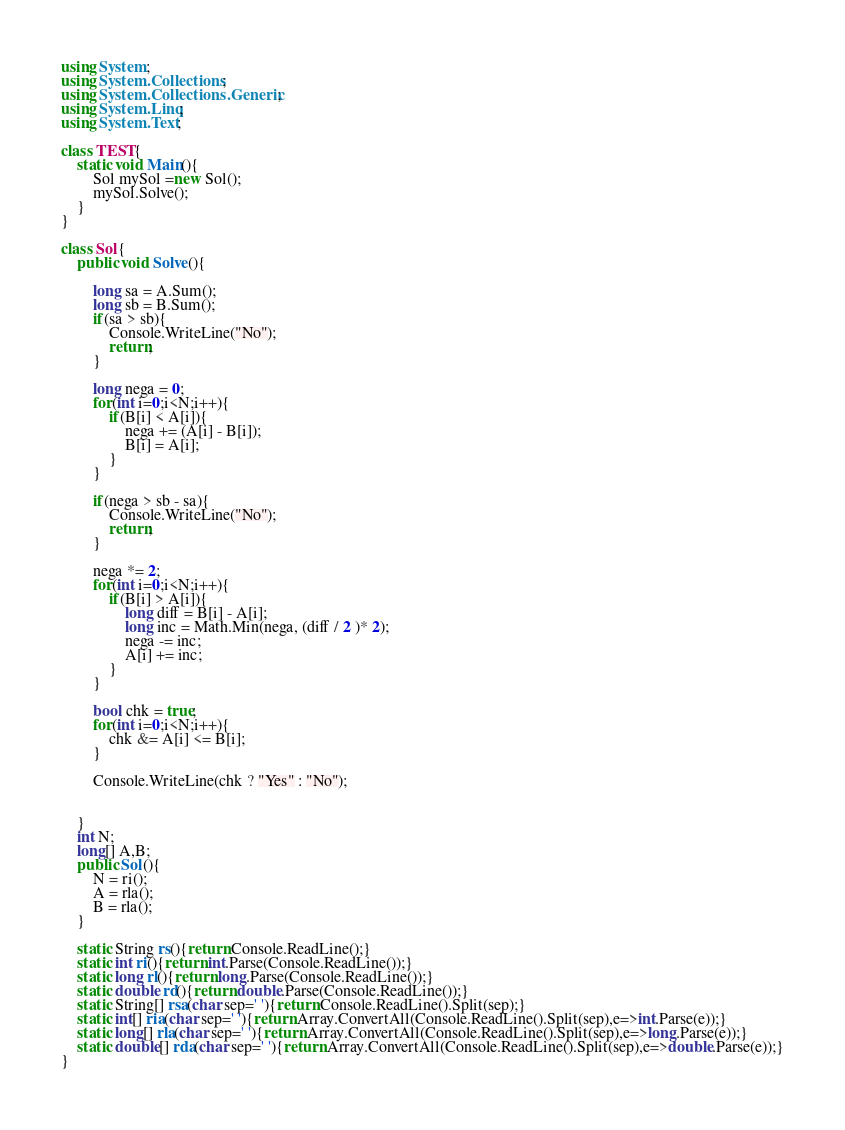Convert code to text. <code><loc_0><loc_0><loc_500><loc_500><_C#_>using System;
using System.Collections;
using System.Collections.Generic;
using System.Linq;
using System.Text;

class TEST{
	static void Main(){
		Sol mySol =new Sol();
		mySol.Solve();
	}
}

class Sol{
	public void Solve(){
		
		long sa = A.Sum();
		long sb = B.Sum();
		if(sa > sb){
			Console.WriteLine("No");
			return;
		}
		
		long nega = 0;
		for(int i=0;i<N;i++){
			if(B[i] < A[i]){
				nega += (A[i] - B[i]);
				B[i] = A[i];
			}
		}
		
		if(nega > sb - sa){
			Console.WriteLine("No");
			return;
		}
		
		nega *= 2;
		for(int i=0;i<N;i++){
			if(B[i] > A[i]){
				long diff = B[i] - A[i];
				long inc = Math.Min(nega, (diff / 2 )* 2);
				nega -= inc;
				A[i] += inc;
			}
		}
		
		bool chk = true;
		for(int i=0;i<N;i++){
			chk &= A[i] <= B[i];
		}
		
		Console.WriteLine(chk ? "Yes" : "No");
		
		
	}
	int N;
	long[] A,B;
	public Sol(){
		N = ri();
		A = rla();
		B = rla();
	}

	static String rs(){return Console.ReadLine();}
	static int ri(){return int.Parse(Console.ReadLine());}
	static long rl(){return long.Parse(Console.ReadLine());}
	static double rd(){return double.Parse(Console.ReadLine());}
	static String[] rsa(char sep=' '){return Console.ReadLine().Split(sep);}
	static int[] ria(char sep=' '){return Array.ConvertAll(Console.ReadLine().Split(sep),e=>int.Parse(e));}
	static long[] rla(char sep=' '){return Array.ConvertAll(Console.ReadLine().Split(sep),e=>long.Parse(e));}
	static double[] rda(char sep=' '){return Array.ConvertAll(Console.ReadLine().Split(sep),e=>double.Parse(e));}
}
</code> 